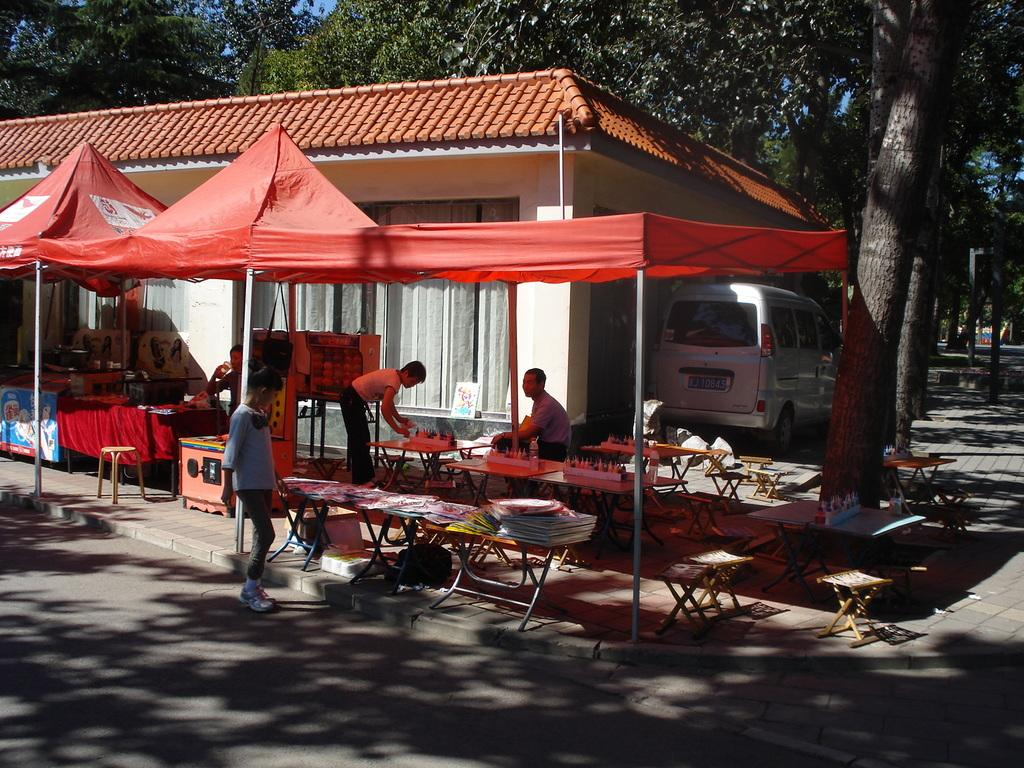What is the main subject of the image? The main subject of the image is a kid. What is the kid wearing? The kid is wearing a white dress. What is the kid looking at in the image? The kid is looking at something on a table. What can be seen in the background of the image? There is a house and a car in the background of the image. What type of cow can be seen grazing in the background of the image? There is no cow present in the image; it features a kid, a white dress, and a table with something on it, along with a house and a car in the background. 